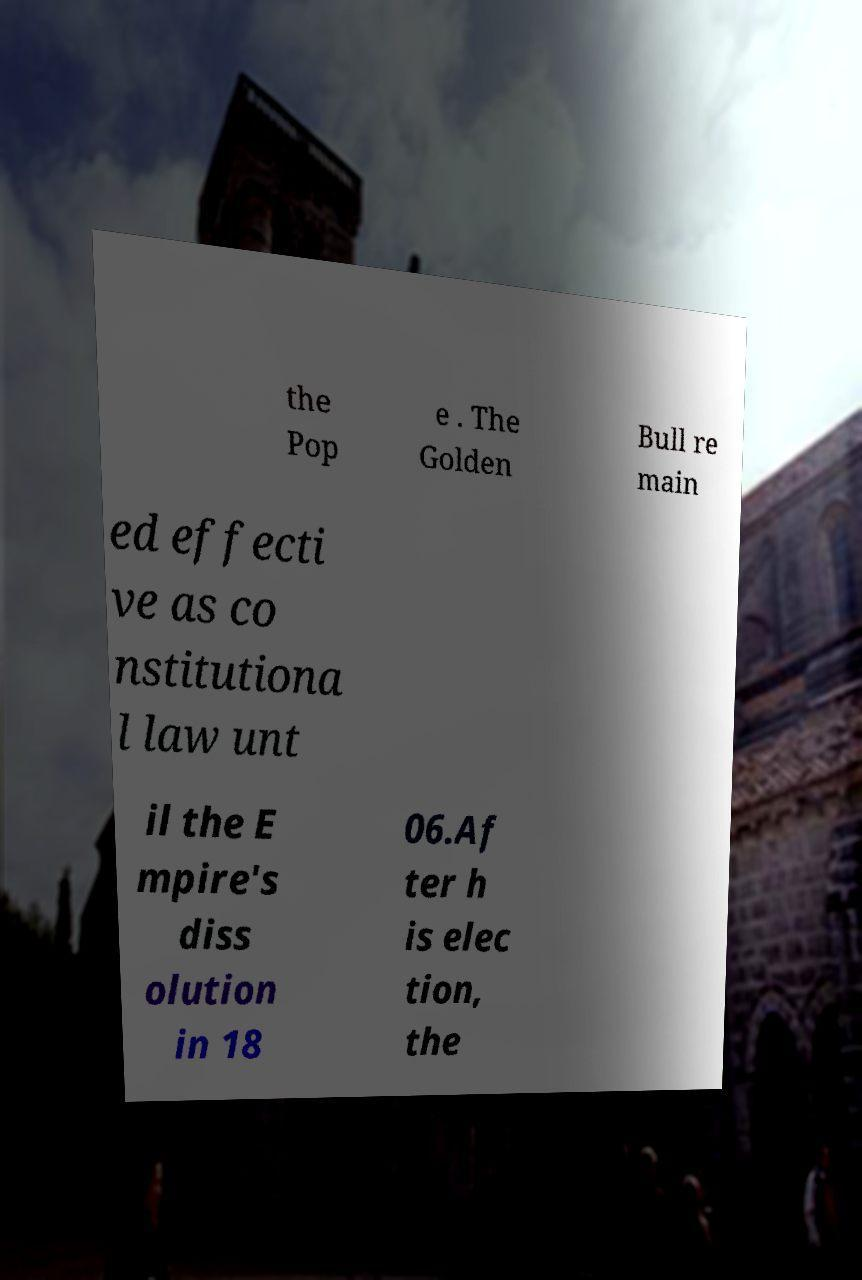Please read and relay the text visible in this image. What does it say? the Pop e . The Golden Bull re main ed effecti ve as co nstitutiona l law unt il the E mpire's diss olution in 18 06.Af ter h is elec tion, the 